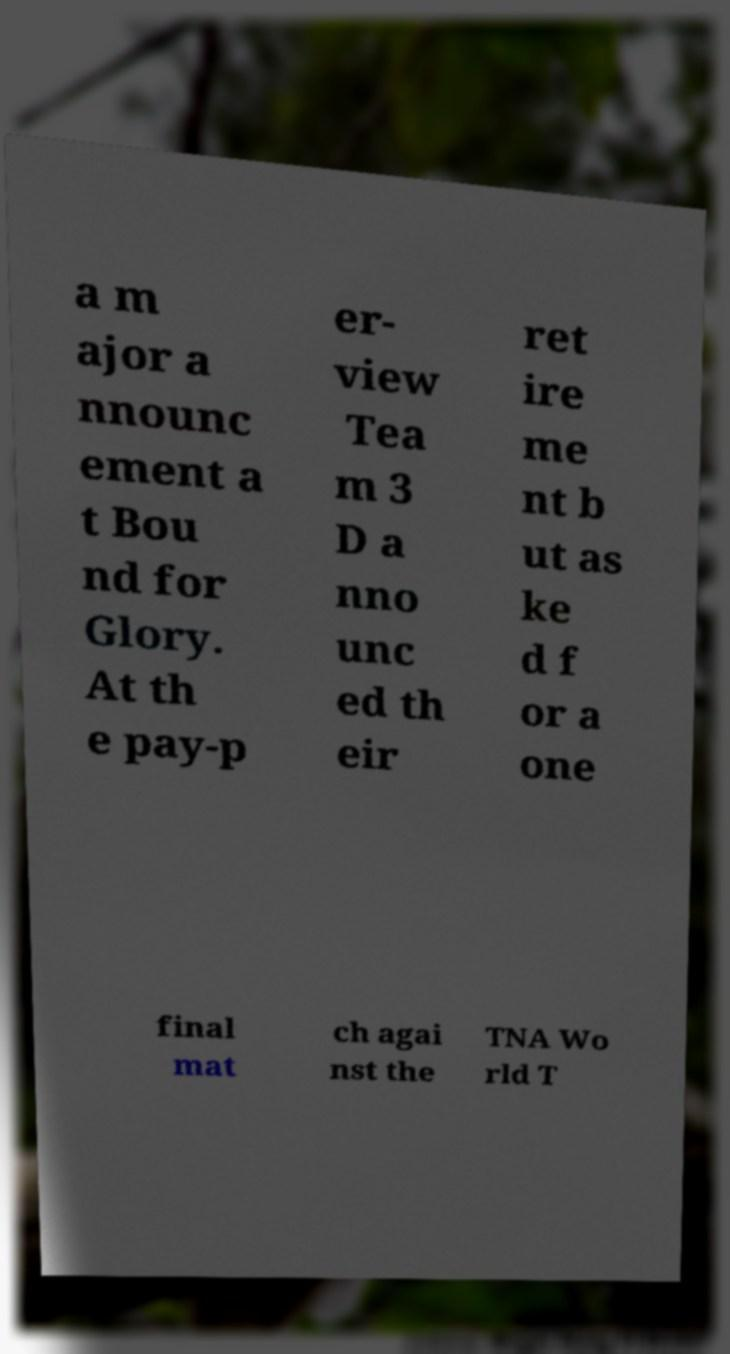Can you accurately transcribe the text from the provided image for me? a m ajor a nnounc ement a t Bou nd for Glory. At th e pay-p er- view Tea m 3 D a nno unc ed th eir ret ire me nt b ut as ke d f or a one final mat ch agai nst the TNA Wo rld T 